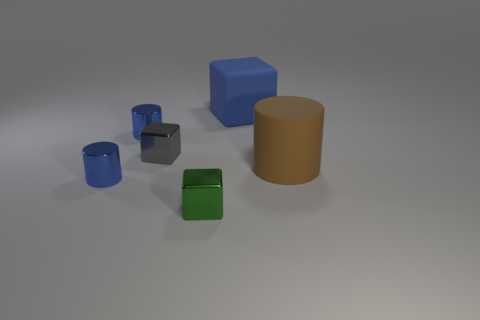Add 2 big objects. How many objects exist? 8 Subtract 0 green spheres. How many objects are left? 6 Subtract all small objects. Subtract all big cubes. How many objects are left? 1 Add 1 blocks. How many blocks are left? 4 Add 6 tiny blue metal objects. How many tiny blue metal objects exist? 8 